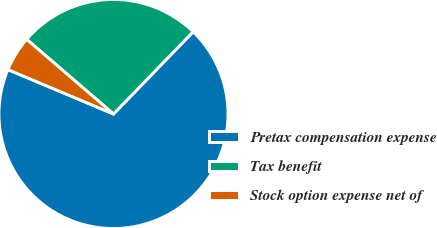Convert chart to OTSL. <chart><loc_0><loc_0><loc_500><loc_500><pie_chart><fcel>Pretax compensation expense<fcel>Tax benefit<fcel>Stock option expense net of<nl><fcel>69.09%<fcel>25.95%<fcel>4.96%<nl></chart> 